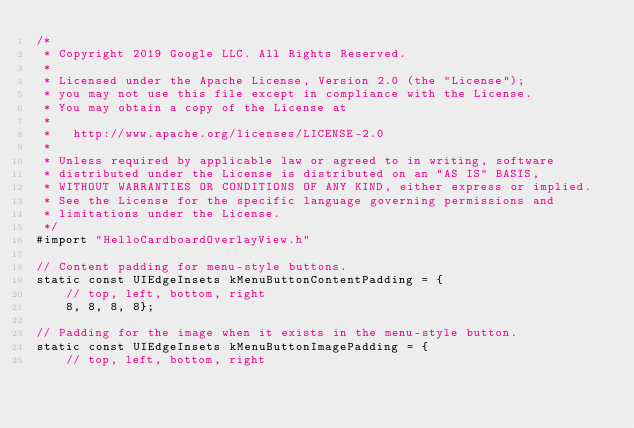Convert code to text. <code><loc_0><loc_0><loc_500><loc_500><_ObjectiveC_>/*
 * Copyright 2019 Google LLC. All Rights Reserved.
 *
 * Licensed under the Apache License, Version 2.0 (the "License");
 * you may not use this file except in compliance with the License.
 * You may obtain a copy of the License at
 *
 *   http://www.apache.org/licenses/LICENSE-2.0
 *
 * Unless required by applicable law or agreed to in writing, software
 * distributed under the License is distributed on an "AS IS" BASIS,
 * WITHOUT WARRANTIES OR CONDITIONS OF ANY KIND, either express or implied.
 * See the License for the specific language governing permissions and
 * limitations under the License.
 */
#import "HelloCardboardOverlayView.h"

// Content padding for menu-style buttons.
static const UIEdgeInsets kMenuButtonContentPadding = {
    // top, left, bottom, right
    8, 8, 8, 8};

// Padding for the image when it exists in the menu-style button.
static const UIEdgeInsets kMenuButtonImagePadding = {
    // top, left, bottom, right</code> 